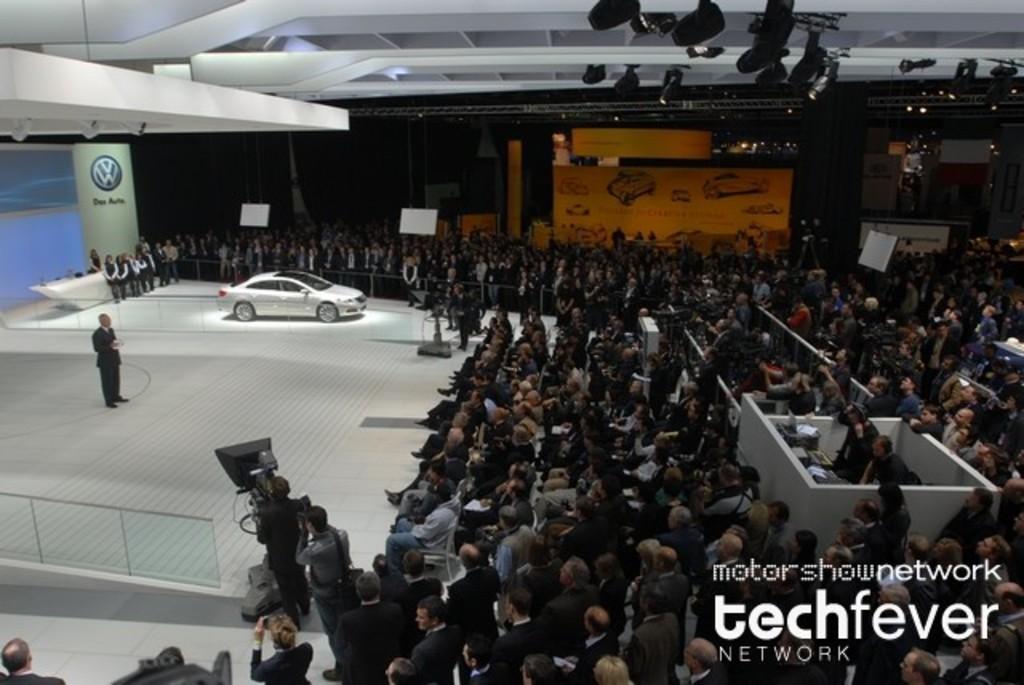Can you describe this image briefly? This image is clicked inside a showroom. There are so many people standing. There is a car in the middle. There are lights at the top. 